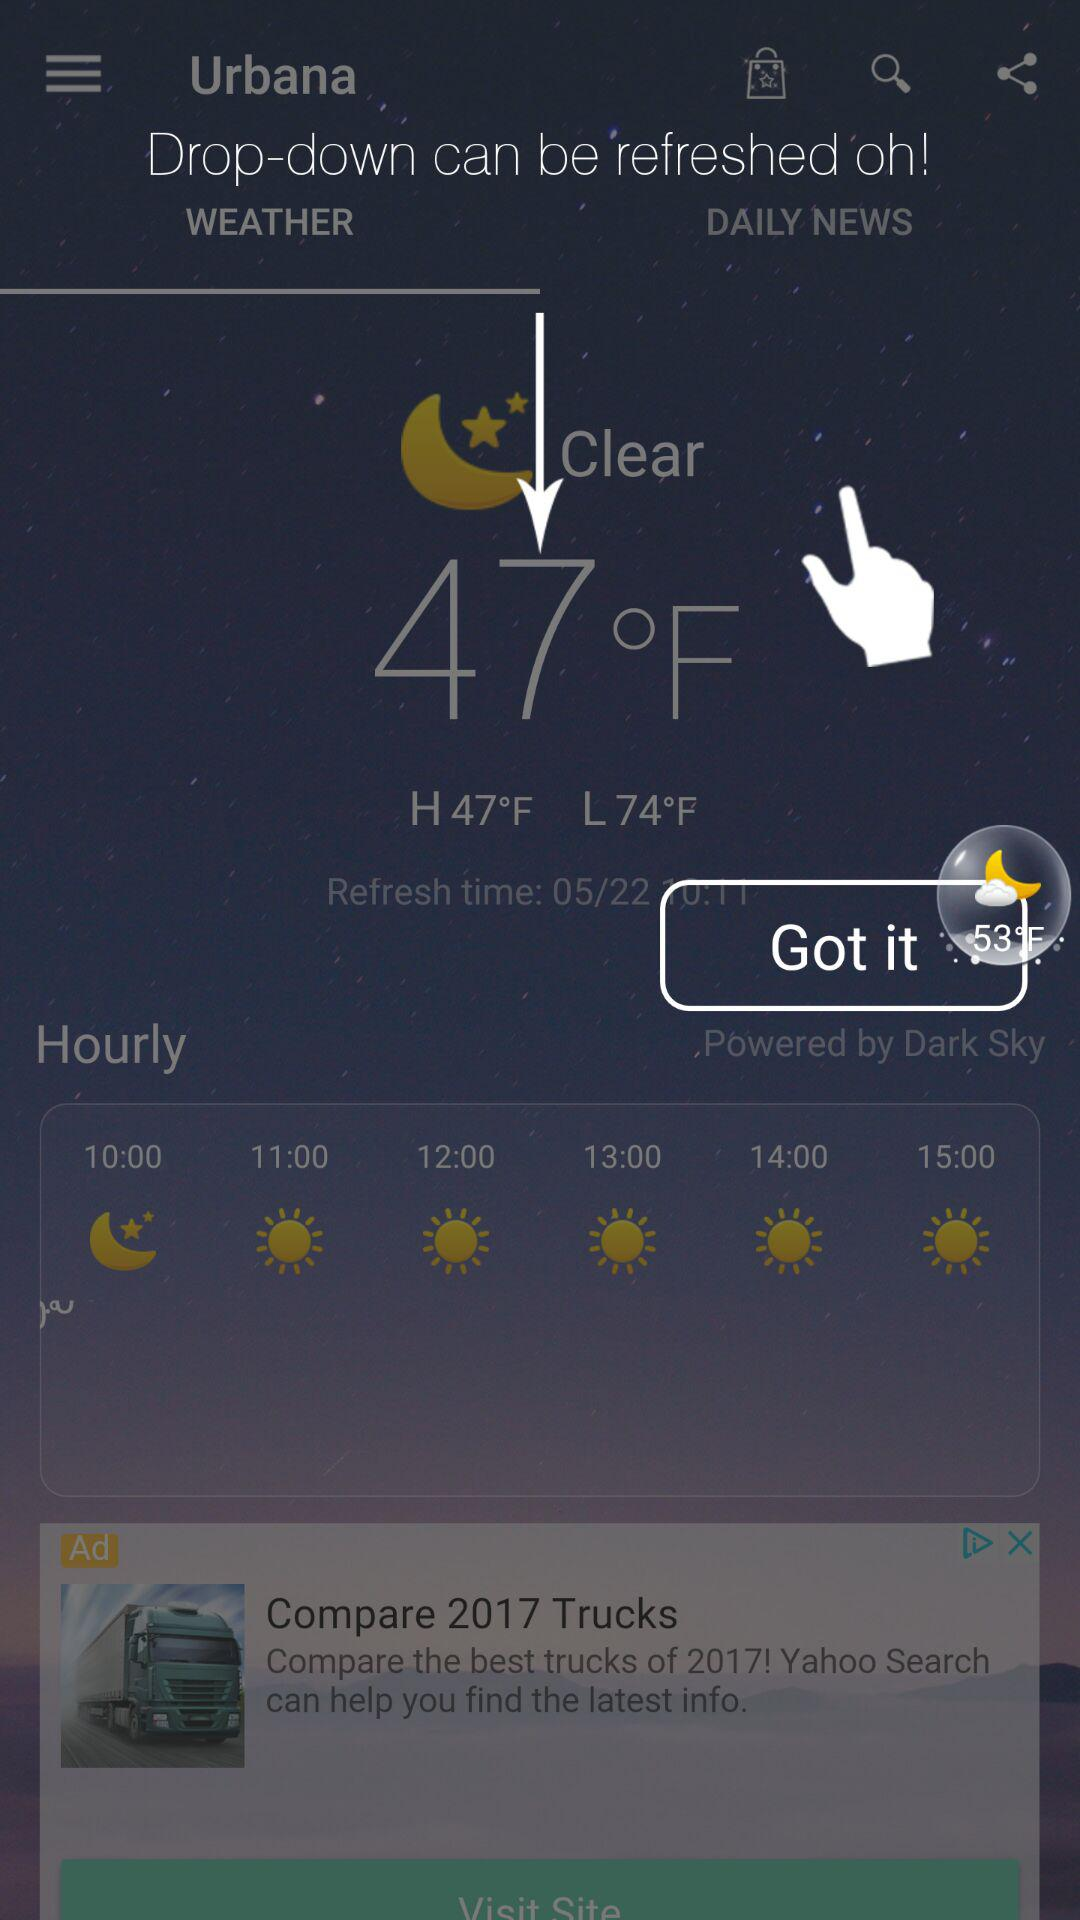What is the refresh time? The refresh time is 10:11. 